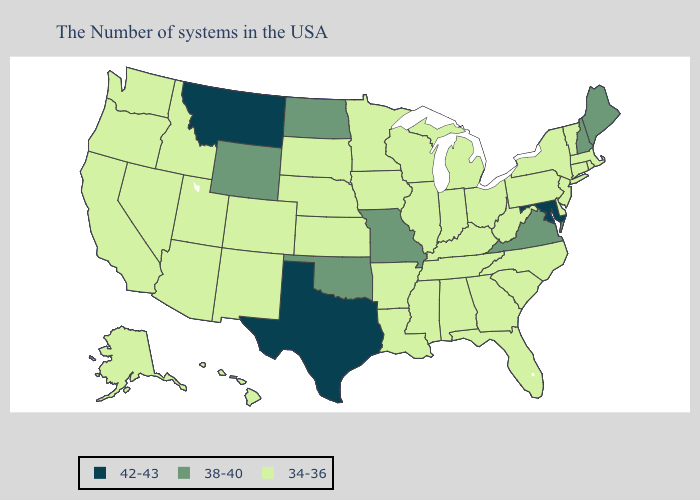Name the states that have a value in the range 38-40?
Write a very short answer. Maine, New Hampshire, Virginia, Missouri, Oklahoma, North Dakota, Wyoming. What is the lowest value in the South?
Keep it brief. 34-36. What is the lowest value in the USA?
Short answer required. 34-36. What is the highest value in states that border Arkansas?
Short answer required. 42-43. What is the highest value in the USA?
Write a very short answer. 42-43. What is the highest value in states that border North Carolina?
Be succinct. 38-40. Name the states that have a value in the range 34-36?
Give a very brief answer. Massachusetts, Rhode Island, Vermont, Connecticut, New York, New Jersey, Delaware, Pennsylvania, North Carolina, South Carolina, West Virginia, Ohio, Florida, Georgia, Michigan, Kentucky, Indiana, Alabama, Tennessee, Wisconsin, Illinois, Mississippi, Louisiana, Arkansas, Minnesota, Iowa, Kansas, Nebraska, South Dakota, Colorado, New Mexico, Utah, Arizona, Idaho, Nevada, California, Washington, Oregon, Alaska, Hawaii. Does Oregon have the highest value in the USA?
Short answer required. No. What is the value of Nevada?
Answer briefly. 34-36. What is the highest value in the South ?
Be succinct. 42-43. How many symbols are there in the legend?
Concise answer only. 3. Which states have the lowest value in the USA?
Keep it brief. Massachusetts, Rhode Island, Vermont, Connecticut, New York, New Jersey, Delaware, Pennsylvania, North Carolina, South Carolina, West Virginia, Ohio, Florida, Georgia, Michigan, Kentucky, Indiana, Alabama, Tennessee, Wisconsin, Illinois, Mississippi, Louisiana, Arkansas, Minnesota, Iowa, Kansas, Nebraska, South Dakota, Colorado, New Mexico, Utah, Arizona, Idaho, Nevada, California, Washington, Oregon, Alaska, Hawaii. Among the states that border New Mexico , does Texas have the lowest value?
Quick response, please. No. Does Maryland have the lowest value in the USA?
Write a very short answer. No. Does South Dakota have the same value as Idaho?
Concise answer only. Yes. 